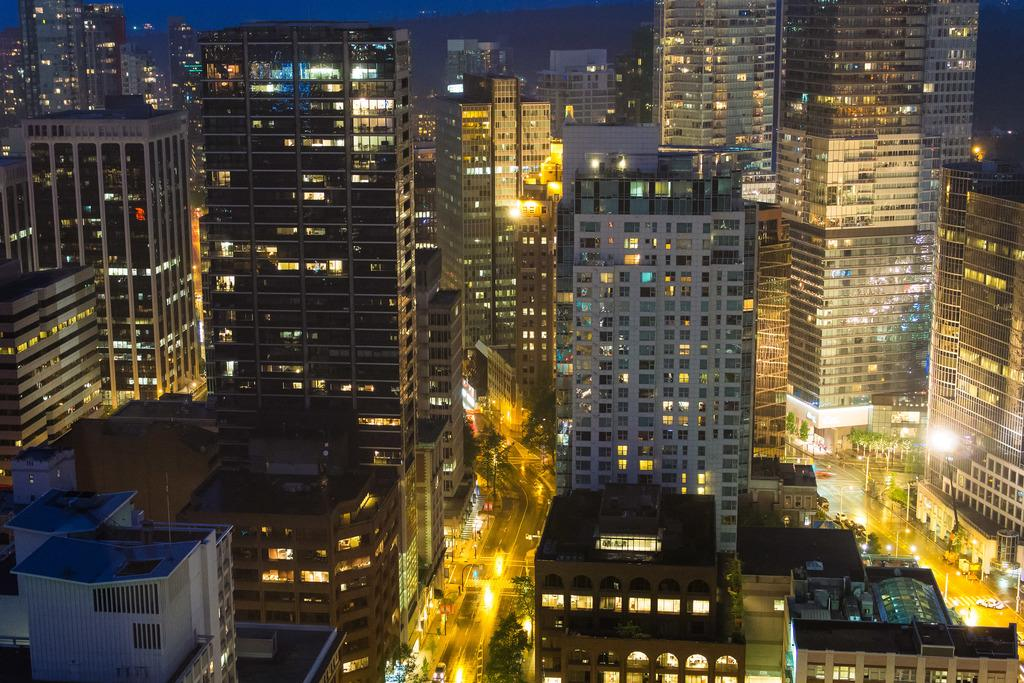What type of structures can be seen in the image? There are buildings in the image. What else is present in the image besides buildings? There are vehicles and trees visible in the image. Can you describe any lighting features in the image? Yes, there are lights in the image. Where is the bedroom located in the image? There is no bedroom present in the image. How does the quicksand affect the vehicles in the image? There is no quicksand present in the image, so it does not affect the vehicles. What route are the vehicles taking in the image? There is no specific route indicated for the vehicles in the image. 